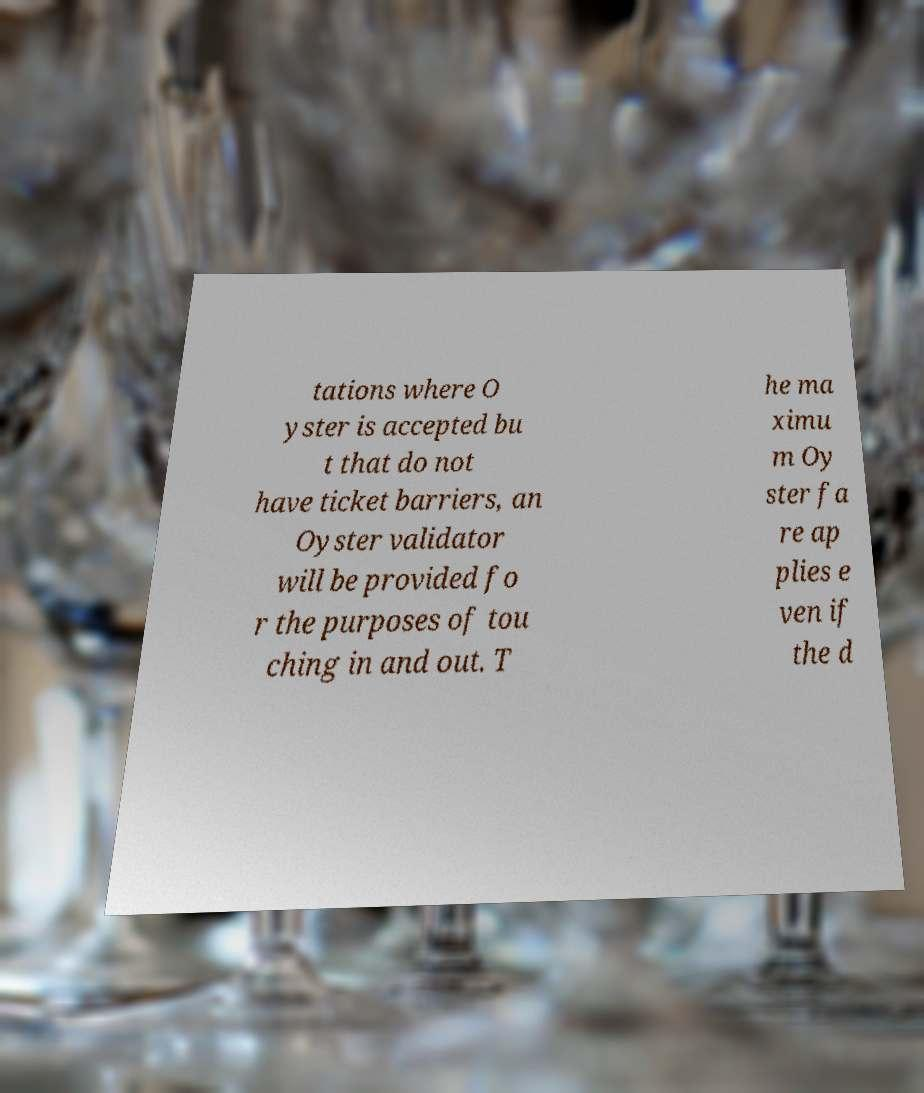There's text embedded in this image that I need extracted. Can you transcribe it verbatim? tations where O yster is accepted bu t that do not have ticket barriers, an Oyster validator will be provided fo r the purposes of tou ching in and out. T he ma ximu m Oy ster fa re ap plies e ven if the d 